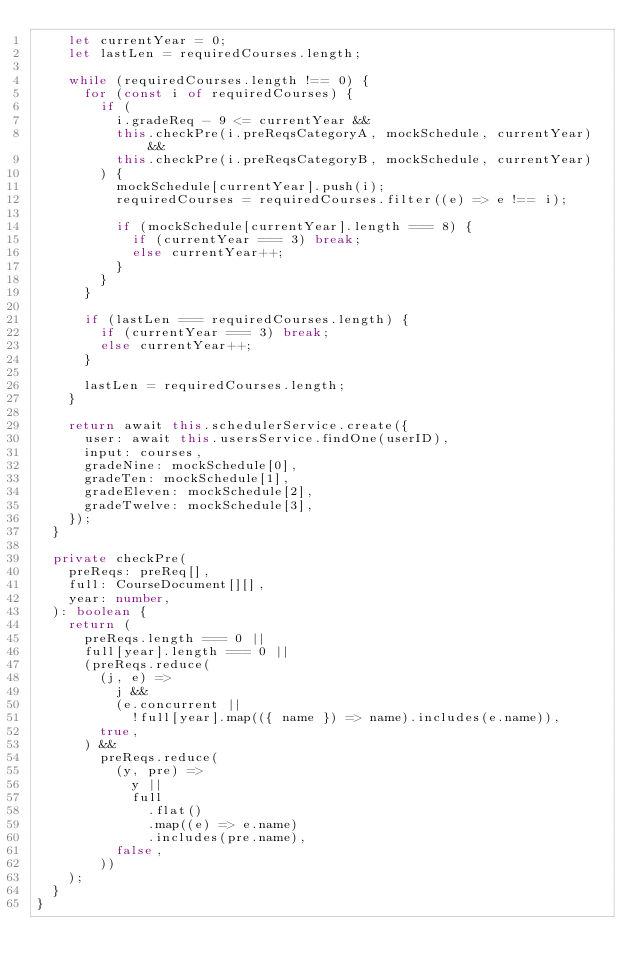Convert code to text. <code><loc_0><loc_0><loc_500><loc_500><_TypeScript_>    let currentYear = 0;
    let lastLen = requiredCourses.length;

    while (requiredCourses.length !== 0) {
      for (const i of requiredCourses) {
        if (
          i.gradeReq - 9 <= currentYear &&
          this.checkPre(i.preReqsCategoryA, mockSchedule, currentYear) &&
          this.checkPre(i.preReqsCategoryB, mockSchedule, currentYear)
        ) {
          mockSchedule[currentYear].push(i);
          requiredCourses = requiredCourses.filter((e) => e !== i);

          if (mockSchedule[currentYear].length === 8) {
            if (currentYear === 3) break;
            else currentYear++;
          }
        }
      }

      if (lastLen === requiredCourses.length) {
        if (currentYear === 3) break;
        else currentYear++;
      }

      lastLen = requiredCourses.length;
    }

    return await this.schedulerService.create({
      user: await this.usersService.findOne(userID),
      input: courses,
      gradeNine: mockSchedule[0],
      gradeTen: mockSchedule[1],
      gradeEleven: mockSchedule[2],
      gradeTwelve: mockSchedule[3],
    });
  }

  private checkPre(
    preReqs: preReq[],
    full: CourseDocument[][],
    year: number,
  ): boolean {
    return (
      preReqs.length === 0 ||
      full[year].length === 0 ||
      (preReqs.reduce(
        (j, e) =>
          j &&
          (e.concurrent ||
            !full[year].map(({ name }) => name).includes(e.name)),
        true,
      ) &&
        preReqs.reduce(
          (y, pre) =>
            y ||
            full
              .flat()
              .map((e) => e.name)
              .includes(pre.name),
          false,
        ))
    );
  }
}
</code> 